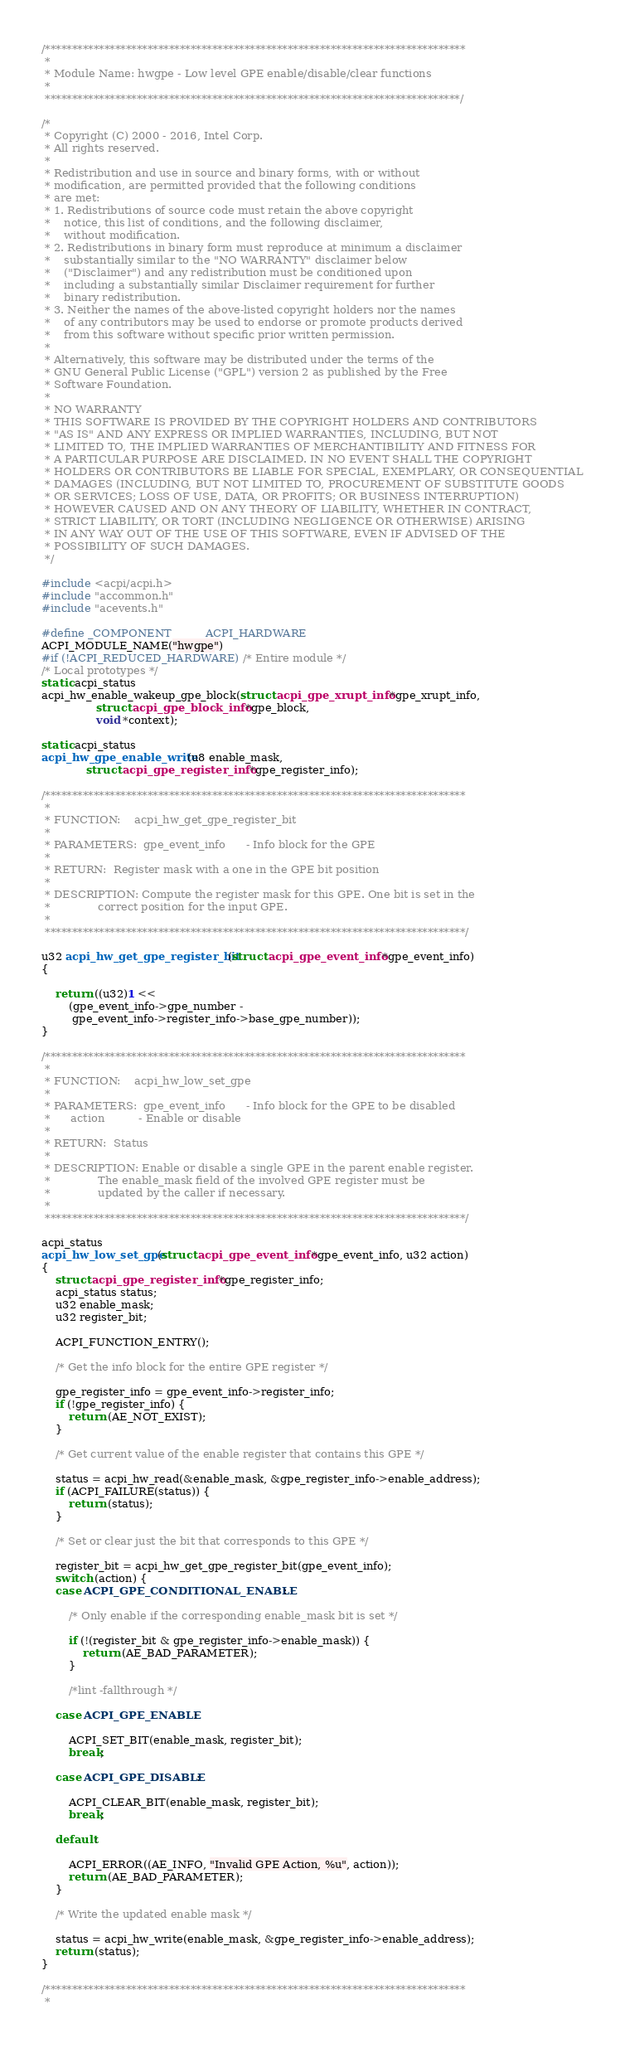<code> <loc_0><loc_0><loc_500><loc_500><_C_>/******************************************************************************
 *
 * Module Name: hwgpe - Low level GPE enable/disable/clear functions
 *
 *****************************************************************************/

/*
 * Copyright (C) 2000 - 2016, Intel Corp.
 * All rights reserved.
 *
 * Redistribution and use in source and binary forms, with or without
 * modification, are permitted provided that the following conditions
 * are met:
 * 1. Redistributions of source code must retain the above copyright
 *    notice, this list of conditions, and the following disclaimer,
 *    without modification.
 * 2. Redistributions in binary form must reproduce at minimum a disclaimer
 *    substantially similar to the "NO WARRANTY" disclaimer below
 *    ("Disclaimer") and any redistribution must be conditioned upon
 *    including a substantially similar Disclaimer requirement for further
 *    binary redistribution.
 * 3. Neither the names of the above-listed copyright holders nor the names
 *    of any contributors may be used to endorse or promote products derived
 *    from this software without specific prior written permission.
 *
 * Alternatively, this software may be distributed under the terms of the
 * GNU General Public License ("GPL") version 2 as published by the Free
 * Software Foundation.
 *
 * NO WARRANTY
 * THIS SOFTWARE IS PROVIDED BY THE COPYRIGHT HOLDERS AND CONTRIBUTORS
 * "AS IS" AND ANY EXPRESS OR IMPLIED WARRANTIES, INCLUDING, BUT NOT
 * LIMITED TO, THE IMPLIED WARRANTIES OF MERCHANTIBILITY AND FITNESS FOR
 * A PARTICULAR PURPOSE ARE DISCLAIMED. IN NO EVENT SHALL THE COPYRIGHT
 * HOLDERS OR CONTRIBUTORS BE LIABLE FOR SPECIAL, EXEMPLARY, OR CONSEQUENTIAL
 * DAMAGES (INCLUDING, BUT NOT LIMITED TO, PROCUREMENT OF SUBSTITUTE GOODS
 * OR SERVICES; LOSS OF USE, DATA, OR PROFITS; OR BUSINESS INTERRUPTION)
 * HOWEVER CAUSED AND ON ANY THEORY OF LIABILITY, WHETHER IN CONTRACT,
 * STRICT LIABILITY, OR TORT (INCLUDING NEGLIGENCE OR OTHERWISE) ARISING
 * IN ANY WAY OUT OF THE USE OF THIS SOFTWARE, EVEN IF ADVISED OF THE
 * POSSIBILITY OF SUCH DAMAGES.
 */

#include <acpi/acpi.h>
#include "accommon.h"
#include "acevents.h"

#define _COMPONENT          ACPI_HARDWARE
ACPI_MODULE_NAME("hwgpe")
#if (!ACPI_REDUCED_HARDWARE)	/* Entire module */
/* Local prototypes */
static acpi_status
acpi_hw_enable_wakeup_gpe_block(struct acpi_gpe_xrupt_info *gpe_xrupt_info,
				struct acpi_gpe_block_info *gpe_block,
				void *context);

static acpi_status
acpi_hw_gpe_enable_write(u8 enable_mask,
			 struct acpi_gpe_register_info *gpe_register_info);

/******************************************************************************
 *
 * FUNCTION:	acpi_hw_get_gpe_register_bit
 *
 * PARAMETERS:	gpe_event_info	    - Info block for the GPE
 *
 * RETURN:	Register mask with a one in the GPE bit position
 *
 * DESCRIPTION: Compute the register mask for this GPE. One bit is set in the
 *              correct position for the input GPE.
 *
 ******************************************************************************/

u32 acpi_hw_get_gpe_register_bit(struct acpi_gpe_event_info *gpe_event_info)
{

	return ((u32)1 <<
		(gpe_event_info->gpe_number -
		 gpe_event_info->register_info->base_gpe_number));
}

/******************************************************************************
 *
 * FUNCTION:	acpi_hw_low_set_gpe
 *
 * PARAMETERS:	gpe_event_info	    - Info block for the GPE to be disabled
 *		action		    - Enable or disable
 *
 * RETURN:	Status
 *
 * DESCRIPTION: Enable or disable a single GPE in the parent enable register.
 *              The enable_mask field of the involved GPE register must be
 *              updated by the caller if necessary.
 *
 ******************************************************************************/

acpi_status
acpi_hw_low_set_gpe(struct acpi_gpe_event_info *gpe_event_info, u32 action)
{
	struct acpi_gpe_register_info *gpe_register_info;
	acpi_status status;
	u32 enable_mask;
	u32 register_bit;

	ACPI_FUNCTION_ENTRY();

	/* Get the info block for the entire GPE register */

	gpe_register_info = gpe_event_info->register_info;
	if (!gpe_register_info) {
		return (AE_NOT_EXIST);
	}

	/* Get current value of the enable register that contains this GPE */

	status = acpi_hw_read(&enable_mask, &gpe_register_info->enable_address);
	if (ACPI_FAILURE(status)) {
		return (status);
	}

	/* Set or clear just the bit that corresponds to this GPE */

	register_bit = acpi_hw_get_gpe_register_bit(gpe_event_info);
	switch (action) {
	case ACPI_GPE_CONDITIONAL_ENABLE:

		/* Only enable if the corresponding enable_mask bit is set */

		if (!(register_bit & gpe_register_info->enable_mask)) {
			return (AE_BAD_PARAMETER);
		}

		/*lint -fallthrough */

	case ACPI_GPE_ENABLE:

		ACPI_SET_BIT(enable_mask, register_bit);
		break;

	case ACPI_GPE_DISABLE:

		ACPI_CLEAR_BIT(enable_mask, register_bit);
		break;

	default:

		ACPI_ERROR((AE_INFO, "Invalid GPE Action, %u", action));
		return (AE_BAD_PARAMETER);
	}

	/* Write the updated enable mask */

	status = acpi_hw_write(enable_mask, &gpe_register_info->enable_address);
	return (status);
}

/******************************************************************************
 *</code> 